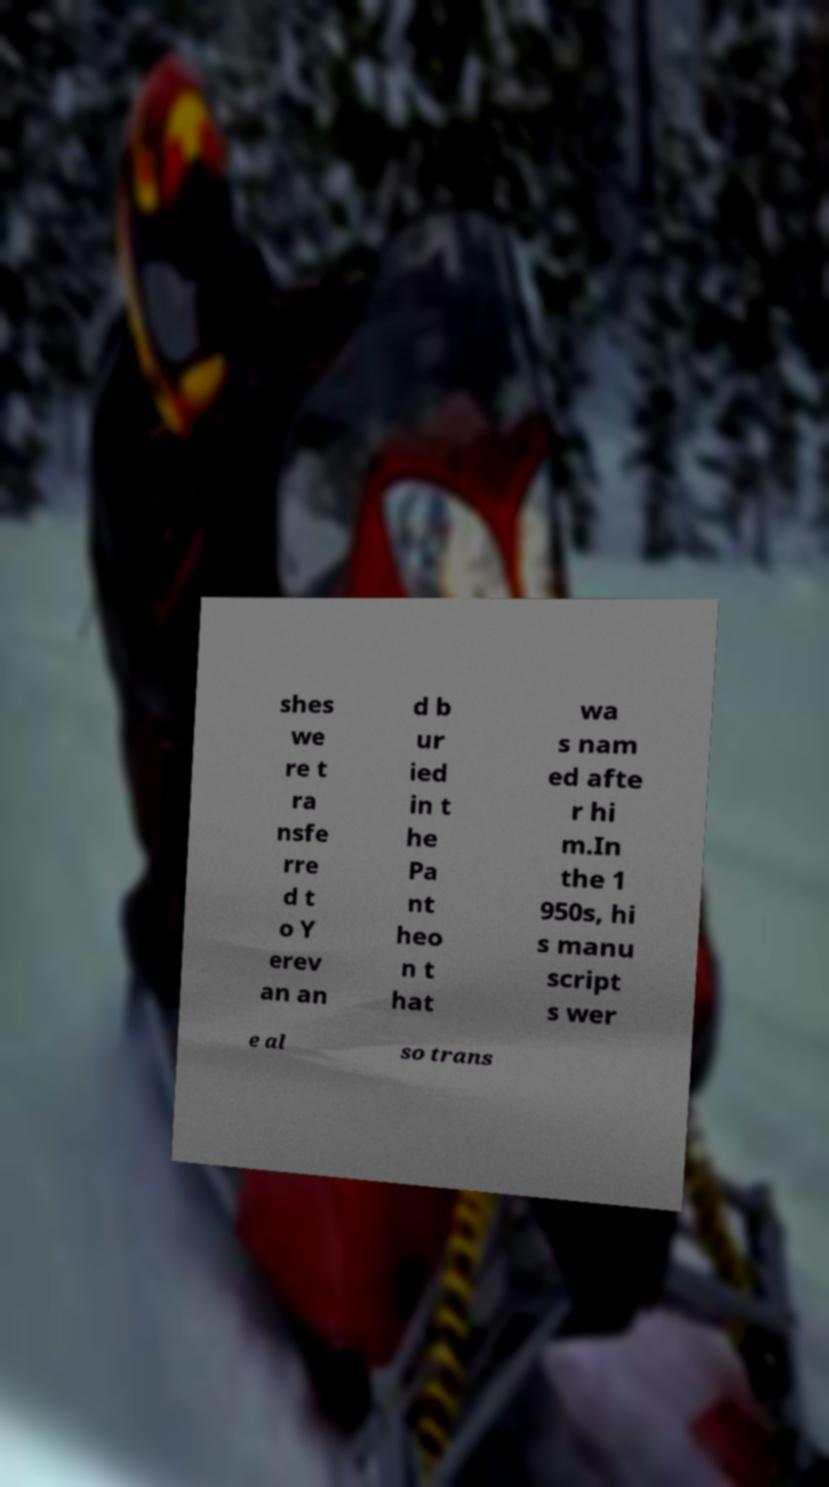What messages or text are displayed in this image? I need them in a readable, typed format. shes we re t ra nsfe rre d t o Y erev an an d b ur ied in t he Pa nt heo n t hat wa s nam ed afte r hi m.In the 1 950s, hi s manu script s wer e al so trans 